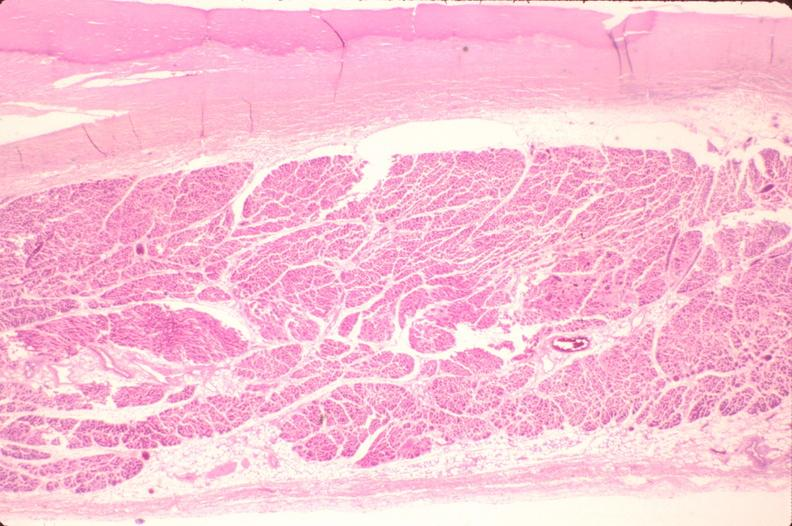what is present?
Answer the question using a single word or phrase. Cardiovascular 